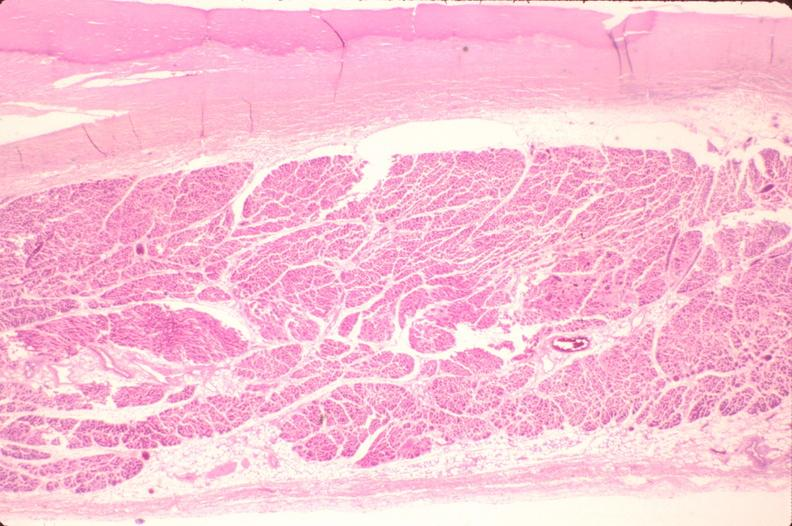what is present?
Answer the question using a single word or phrase. Cardiovascular 